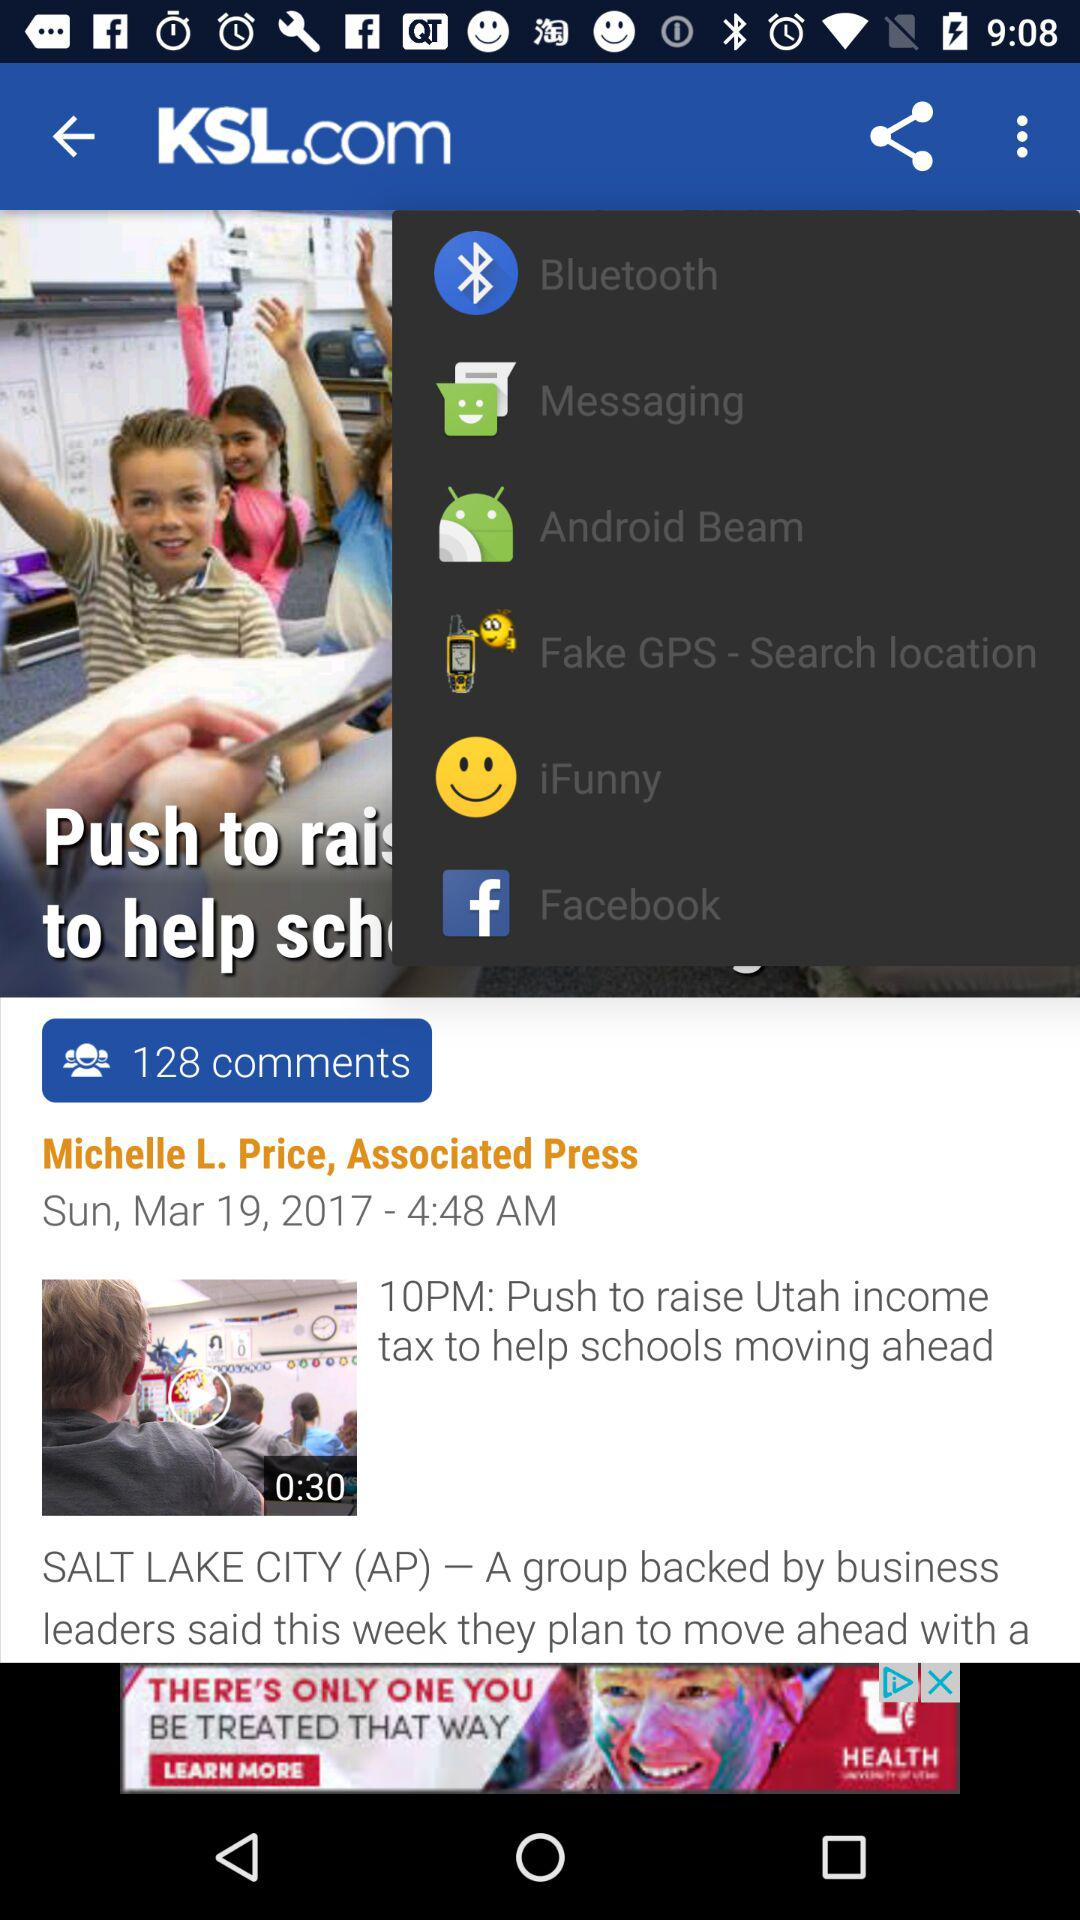What is the duration of the video? The duration is 30 seconds. 